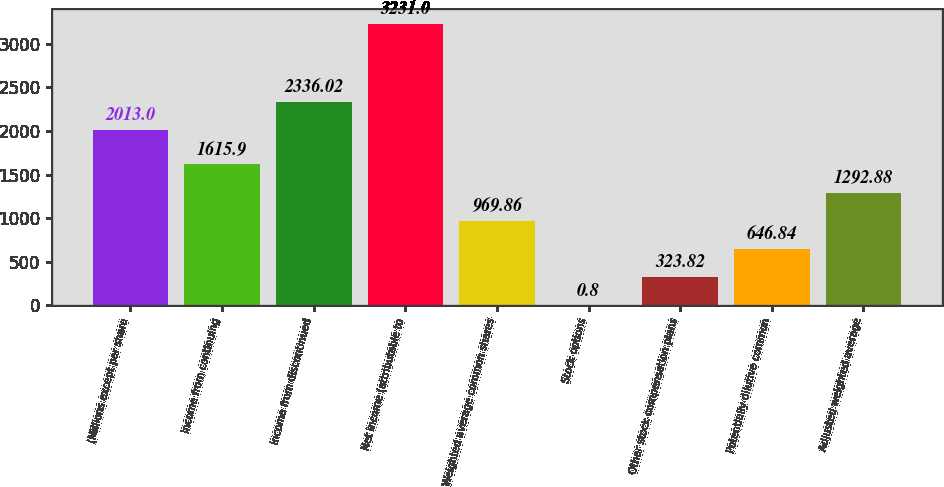Convert chart to OTSL. <chart><loc_0><loc_0><loc_500><loc_500><bar_chart><fcel>(Millions except per share<fcel>Income from continuing<fcel>Income from discontinued<fcel>Net income (attributable to<fcel>Weighted average common shares<fcel>Stock options<fcel>Other stock compensation plans<fcel>Potentially dilutive common<fcel>Adjusted weighted average<nl><fcel>2013<fcel>1615.9<fcel>2336.02<fcel>3231<fcel>969.86<fcel>0.8<fcel>323.82<fcel>646.84<fcel>1292.88<nl></chart> 